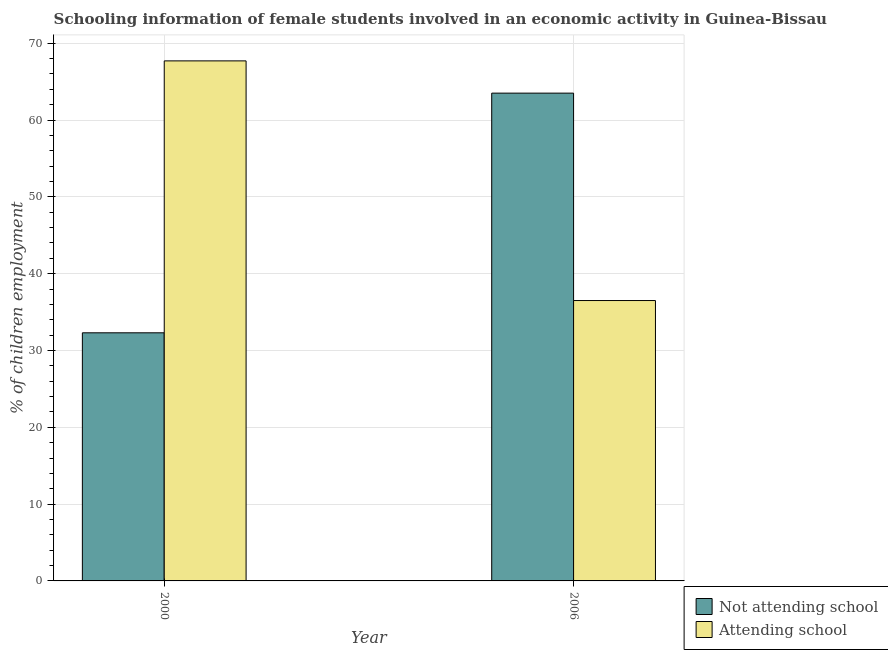Are the number of bars per tick equal to the number of legend labels?
Your response must be concise. Yes. Are the number of bars on each tick of the X-axis equal?
Offer a terse response. Yes. How many bars are there on the 1st tick from the left?
Your response must be concise. 2. How many bars are there on the 2nd tick from the right?
Your answer should be compact. 2. What is the label of the 2nd group of bars from the left?
Make the answer very short. 2006. What is the percentage of employed females who are attending school in 2000?
Make the answer very short. 67.7. Across all years, what is the maximum percentage of employed females who are attending school?
Offer a very short reply. 67.7. Across all years, what is the minimum percentage of employed females who are not attending school?
Your answer should be compact. 32.3. In which year was the percentage of employed females who are attending school minimum?
Keep it short and to the point. 2006. What is the total percentage of employed females who are attending school in the graph?
Your answer should be compact. 104.2. What is the difference between the percentage of employed females who are not attending school in 2000 and that in 2006?
Give a very brief answer. -31.2. What is the difference between the percentage of employed females who are not attending school in 2006 and the percentage of employed females who are attending school in 2000?
Make the answer very short. 31.2. What is the average percentage of employed females who are attending school per year?
Ensure brevity in your answer.  52.1. In how many years, is the percentage of employed females who are attending school greater than 32 %?
Your response must be concise. 2. What is the ratio of the percentage of employed females who are not attending school in 2000 to that in 2006?
Your answer should be compact. 0.51. In how many years, is the percentage of employed females who are not attending school greater than the average percentage of employed females who are not attending school taken over all years?
Give a very brief answer. 1. What does the 1st bar from the left in 2000 represents?
Offer a terse response. Not attending school. What does the 1st bar from the right in 2006 represents?
Give a very brief answer. Attending school. Are all the bars in the graph horizontal?
Provide a succinct answer. No. How many years are there in the graph?
Ensure brevity in your answer.  2. What is the difference between two consecutive major ticks on the Y-axis?
Offer a very short reply. 10. Are the values on the major ticks of Y-axis written in scientific E-notation?
Provide a succinct answer. No. Does the graph contain any zero values?
Keep it short and to the point. No. How are the legend labels stacked?
Make the answer very short. Vertical. What is the title of the graph?
Provide a succinct answer. Schooling information of female students involved in an economic activity in Guinea-Bissau. What is the label or title of the X-axis?
Keep it short and to the point. Year. What is the label or title of the Y-axis?
Ensure brevity in your answer.  % of children employment. What is the % of children employment in Not attending school in 2000?
Offer a terse response. 32.3. What is the % of children employment in Attending school in 2000?
Your response must be concise. 67.7. What is the % of children employment in Not attending school in 2006?
Keep it short and to the point. 63.5. What is the % of children employment of Attending school in 2006?
Provide a succinct answer. 36.5. Across all years, what is the maximum % of children employment of Not attending school?
Offer a very short reply. 63.5. Across all years, what is the maximum % of children employment in Attending school?
Give a very brief answer. 67.7. Across all years, what is the minimum % of children employment in Not attending school?
Provide a succinct answer. 32.3. Across all years, what is the minimum % of children employment in Attending school?
Your answer should be compact. 36.5. What is the total % of children employment in Not attending school in the graph?
Give a very brief answer. 95.8. What is the total % of children employment in Attending school in the graph?
Your response must be concise. 104.2. What is the difference between the % of children employment in Not attending school in 2000 and that in 2006?
Your answer should be compact. -31.2. What is the difference between the % of children employment in Attending school in 2000 and that in 2006?
Offer a terse response. 31.2. What is the average % of children employment in Not attending school per year?
Offer a very short reply. 47.9. What is the average % of children employment of Attending school per year?
Offer a very short reply. 52.1. In the year 2000, what is the difference between the % of children employment in Not attending school and % of children employment in Attending school?
Keep it short and to the point. -35.4. In the year 2006, what is the difference between the % of children employment in Not attending school and % of children employment in Attending school?
Your answer should be compact. 27. What is the ratio of the % of children employment in Not attending school in 2000 to that in 2006?
Keep it short and to the point. 0.51. What is the ratio of the % of children employment in Attending school in 2000 to that in 2006?
Make the answer very short. 1.85. What is the difference between the highest and the second highest % of children employment in Not attending school?
Ensure brevity in your answer.  31.2. What is the difference between the highest and the second highest % of children employment of Attending school?
Keep it short and to the point. 31.2. What is the difference between the highest and the lowest % of children employment in Not attending school?
Provide a succinct answer. 31.2. What is the difference between the highest and the lowest % of children employment of Attending school?
Offer a terse response. 31.2. 